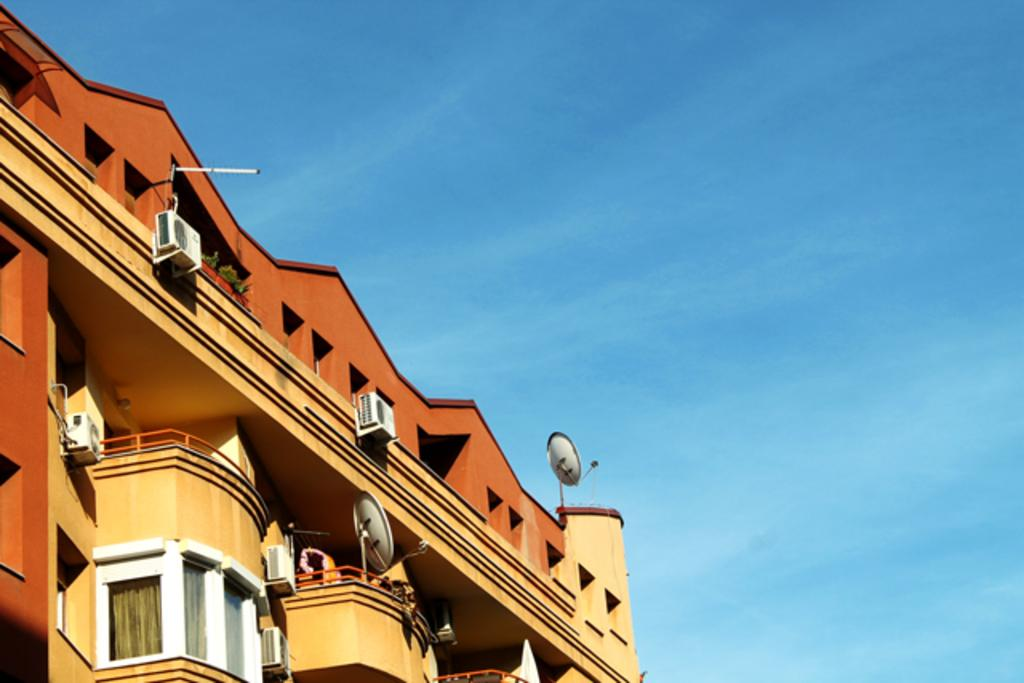What structure is the main subject of the image? There is a building in the image. What can be seen in the background of the image? The sky is visible in the background of the image. What is the color of the sky in the image? The color of the sky is blue. What type of vest is being taught in the image? There is no vest or teaching activity present in the image. 